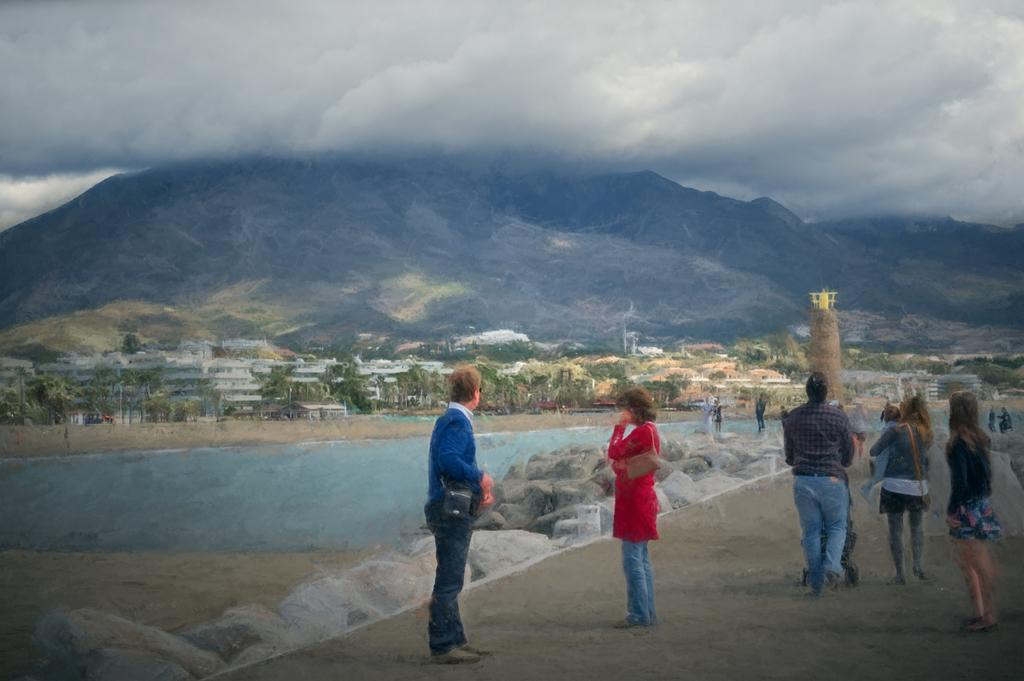What is happening on the ground in the image? There are people on the ground in the image. What type of natural elements can be seen in the image? There are stones, trees, and mountains visible in the image. What type of man-made structures are present in the image? There are buildings in the image. What else can be seen in the image besides the people, stones, trees, and buildings? There are objects in the image. What is visible in the background of the image? The sky and mountains are visible in the background of the image. Where is the kitty hiding in the image? There is no kitty present in the image. What type of jewelry is the person wearing in the image? There is no jewelry visible in the image. 